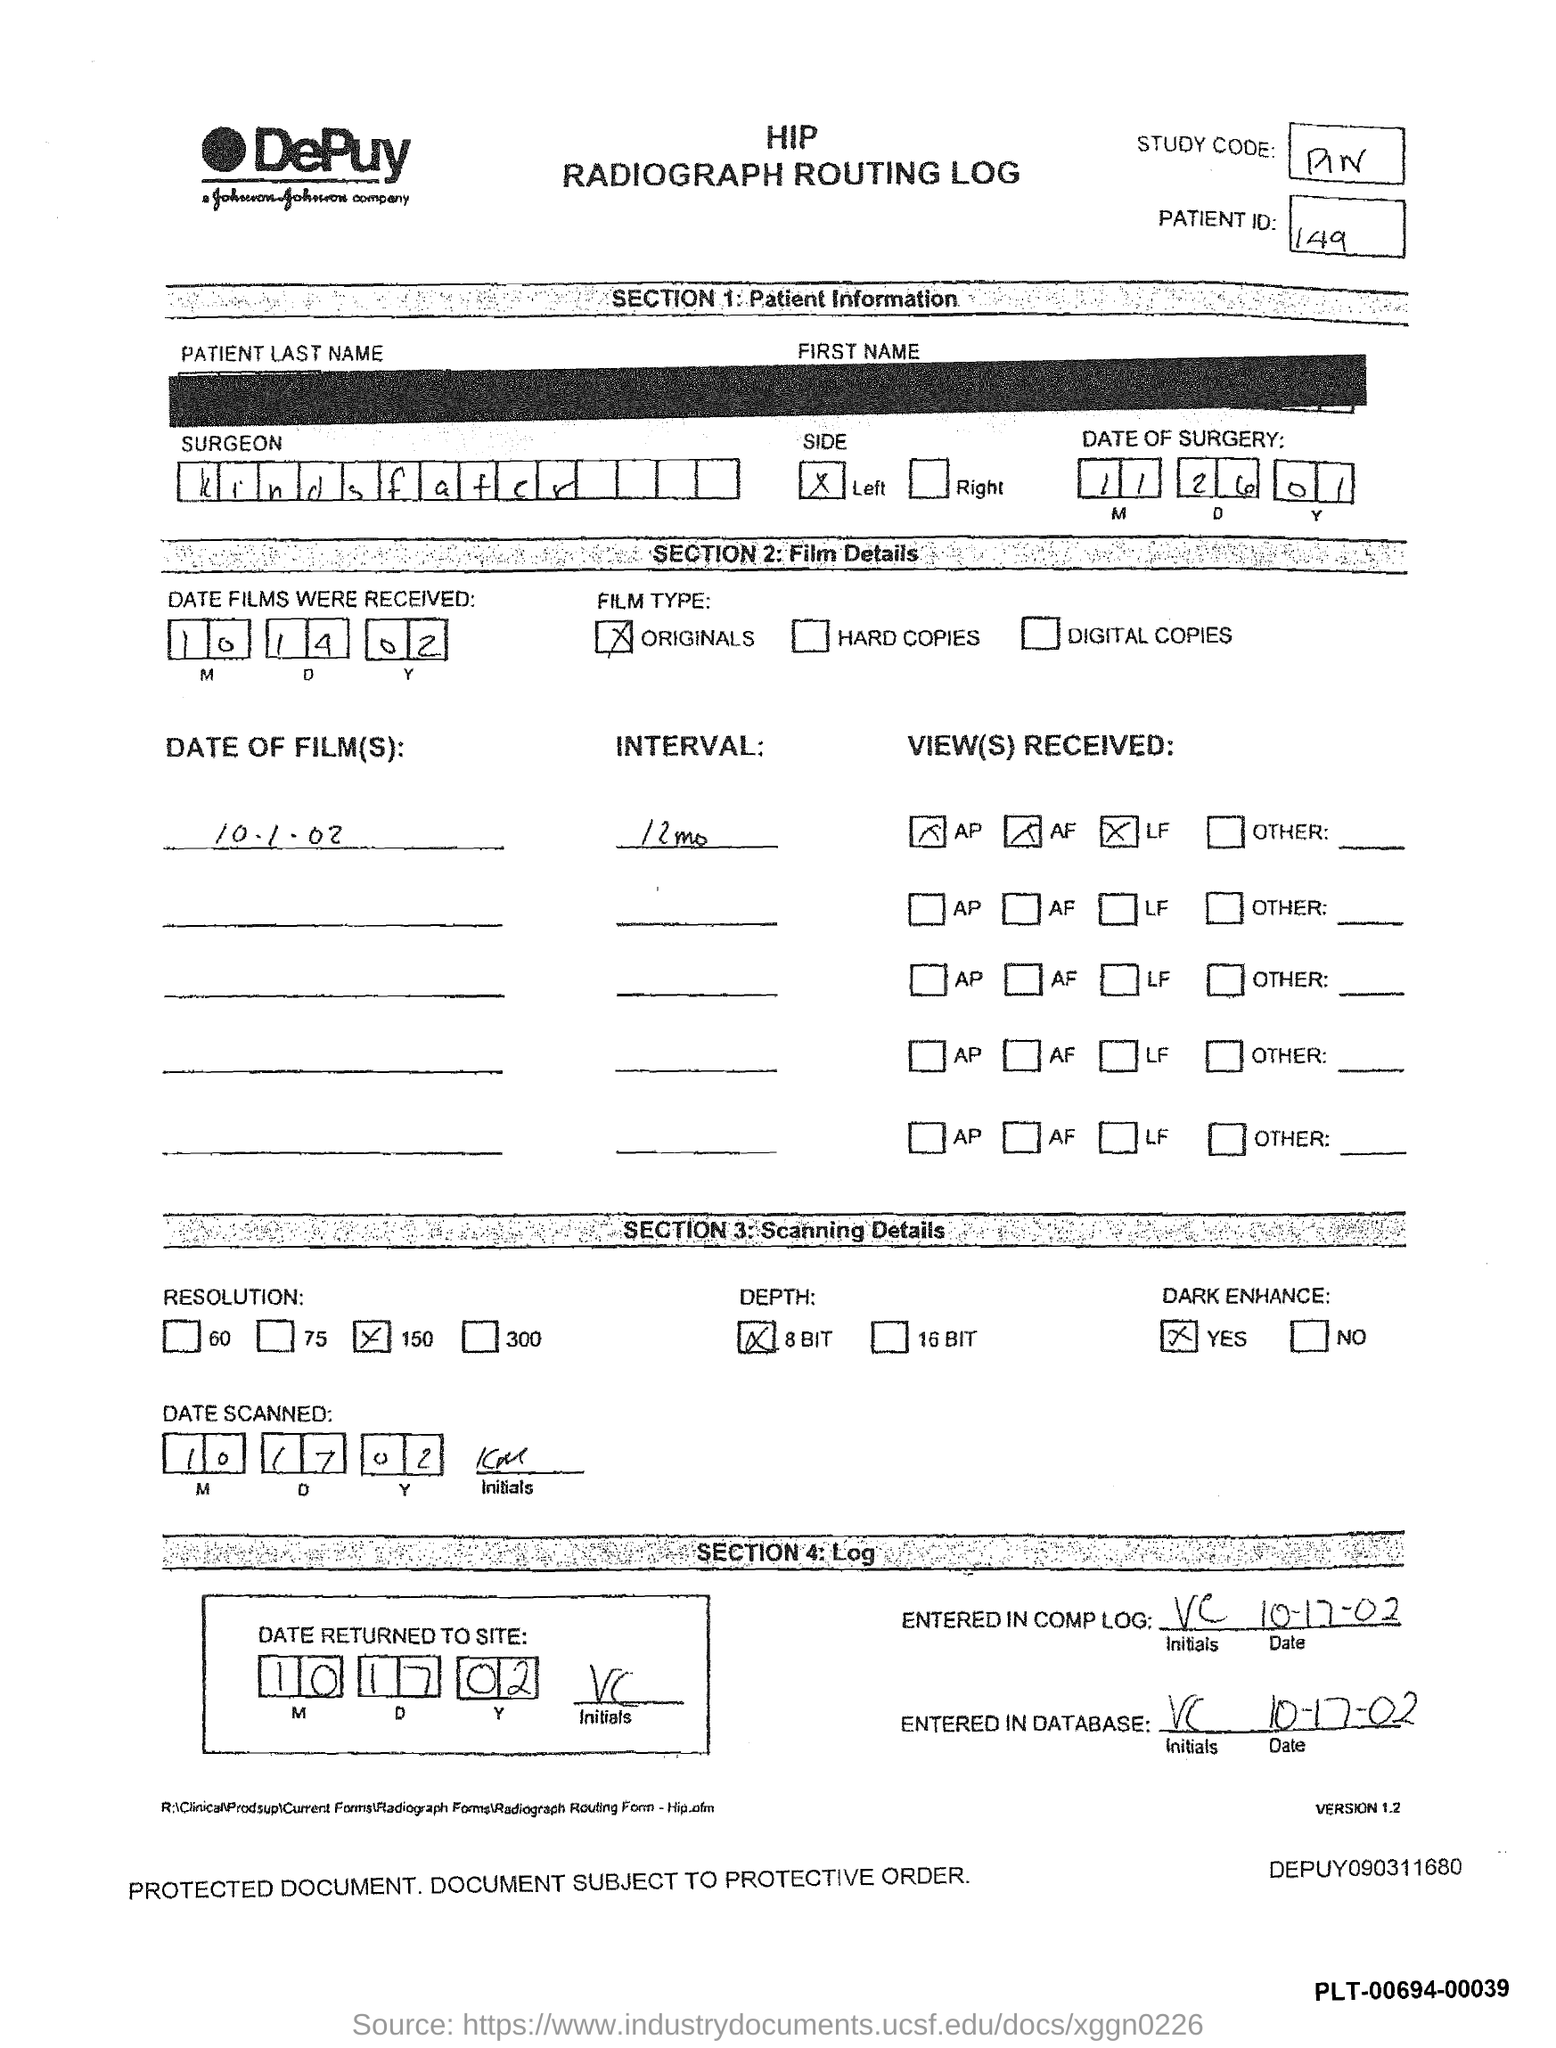Identify some key points in this picture. The surgeon named in the hip radiography routing log is Kindsfater. The patient ID mentioned in the hip radiography routing log is 149. What is the date of the surgery mentioned in the Hip radiography routing log? 11/26/01. The dates on which the films were received are 10, 14, and 02. 